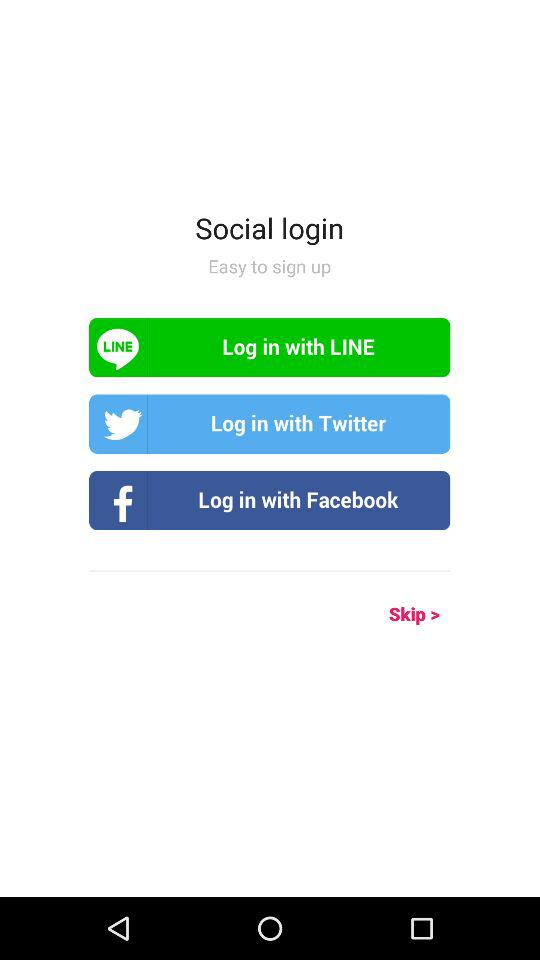When was the last login?
When the provided information is insufficient, respond with <no answer>. <no answer> 